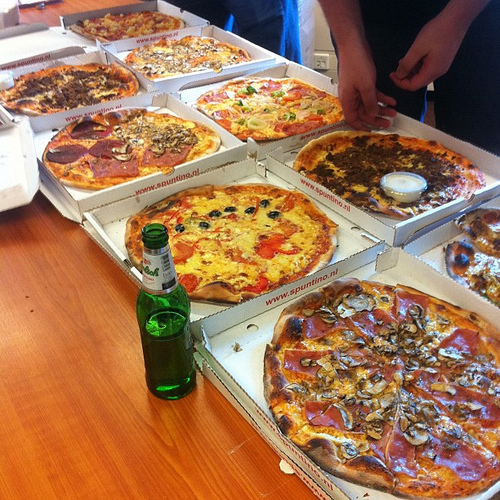Is there a white plate or bottle? No, there isn't a white plate or bottle. 